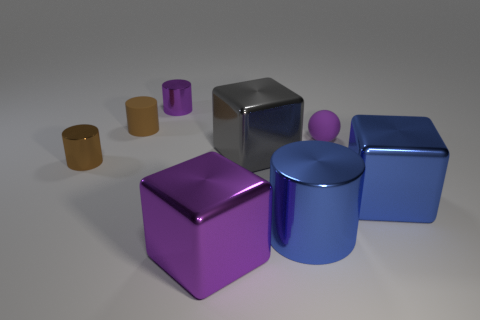There is a metallic cylinder that is the same color as the ball; what is its size?
Offer a terse response. Small. There is a gray metallic object to the left of the small purple rubber sphere; does it have the same shape as the small metal thing that is behind the small brown metallic thing?
Keep it short and to the point. No. What is the material of the gray object?
Ensure brevity in your answer.  Metal. What material is the tiny object in front of the big gray object?
Keep it short and to the point. Metal. Is there anything else of the same color as the small rubber cylinder?
Give a very brief answer. Yes. There is a blue cylinder that is the same material as the purple block; what is its size?
Your answer should be very brief. Large. How many small objects are either brown cylinders or blue metallic cubes?
Your answer should be very brief. 2. What is the size of the purple metallic object behind the big shiny cube to the right of the metallic cube that is behind the large blue shiny cube?
Ensure brevity in your answer.  Small. How many green balls have the same size as the blue cylinder?
Offer a very short reply. 0. How many things are either small red metallic blocks or brown cylinders left of the matte cylinder?
Your answer should be compact. 1. 